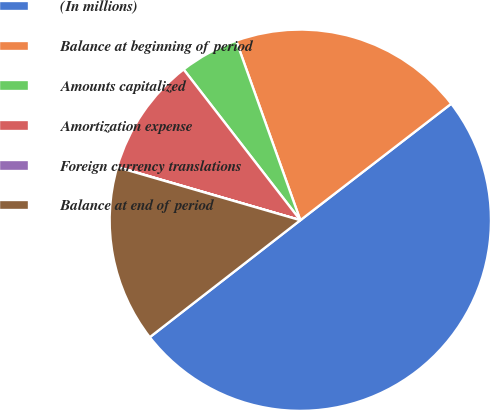<chart> <loc_0><loc_0><loc_500><loc_500><pie_chart><fcel>(In millions)<fcel>Balance at beginning of period<fcel>Amounts capitalized<fcel>Amortization expense<fcel>Foreign currency translations<fcel>Balance at end of period<nl><fcel>49.95%<fcel>20.0%<fcel>5.02%<fcel>10.01%<fcel>0.02%<fcel>15.0%<nl></chart> 